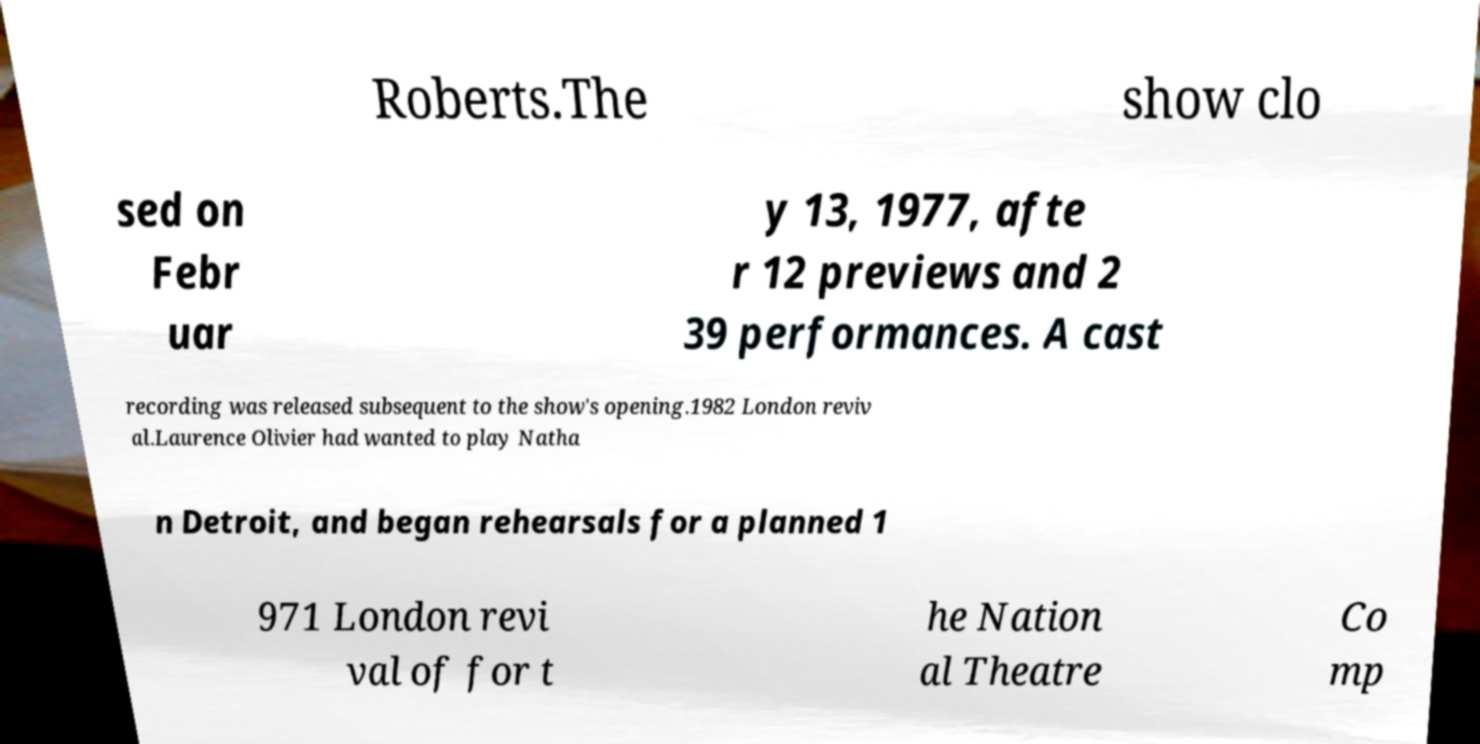Please read and relay the text visible in this image. What does it say? Roberts.The show clo sed on Febr uar y 13, 1977, afte r 12 previews and 2 39 performances. A cast recording was released subsequent to the show's opening.1982 London reviv al.Laurence Olivier had wanted to play Natha n Detroit, and began rehearsals for a planned 1 971 London revi val of for t he Nation al Theatre Co mp 